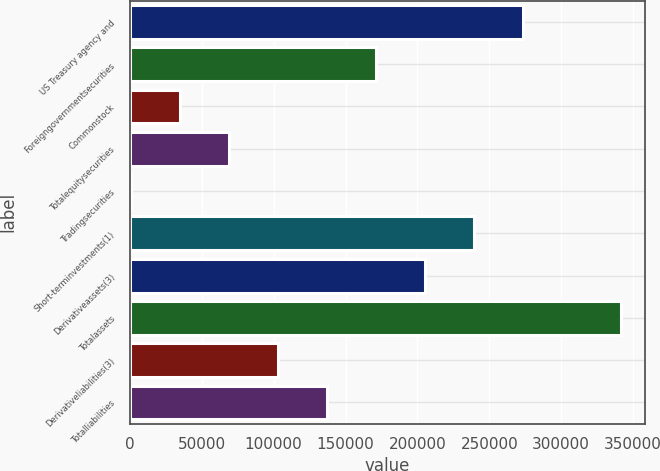Convert chart to OTSL. <chart><loc_0><loc_0><loc_500><loc_500><bar_chart><fcel>US Treasury agency and<fcel>Foreigngovernmentsecurities<fcel>Commonstock<fcel>Totalequitysecurities<fcel>Tradingsecurities<fcel>Short-terminvestments(1)<fcel>Derivativeassets(3)<fcel>Totalassets<fcel>Derivativeliabilities(3)<fcel>Totalliabilities<nl><fcel>273367<fcel>171209<fcel>34998.6<fcel>69051.2<fcel>946<fcel>239314<fcel>205262<fcel>341472<fcel>103104<fcel>137156<nl></chart> 